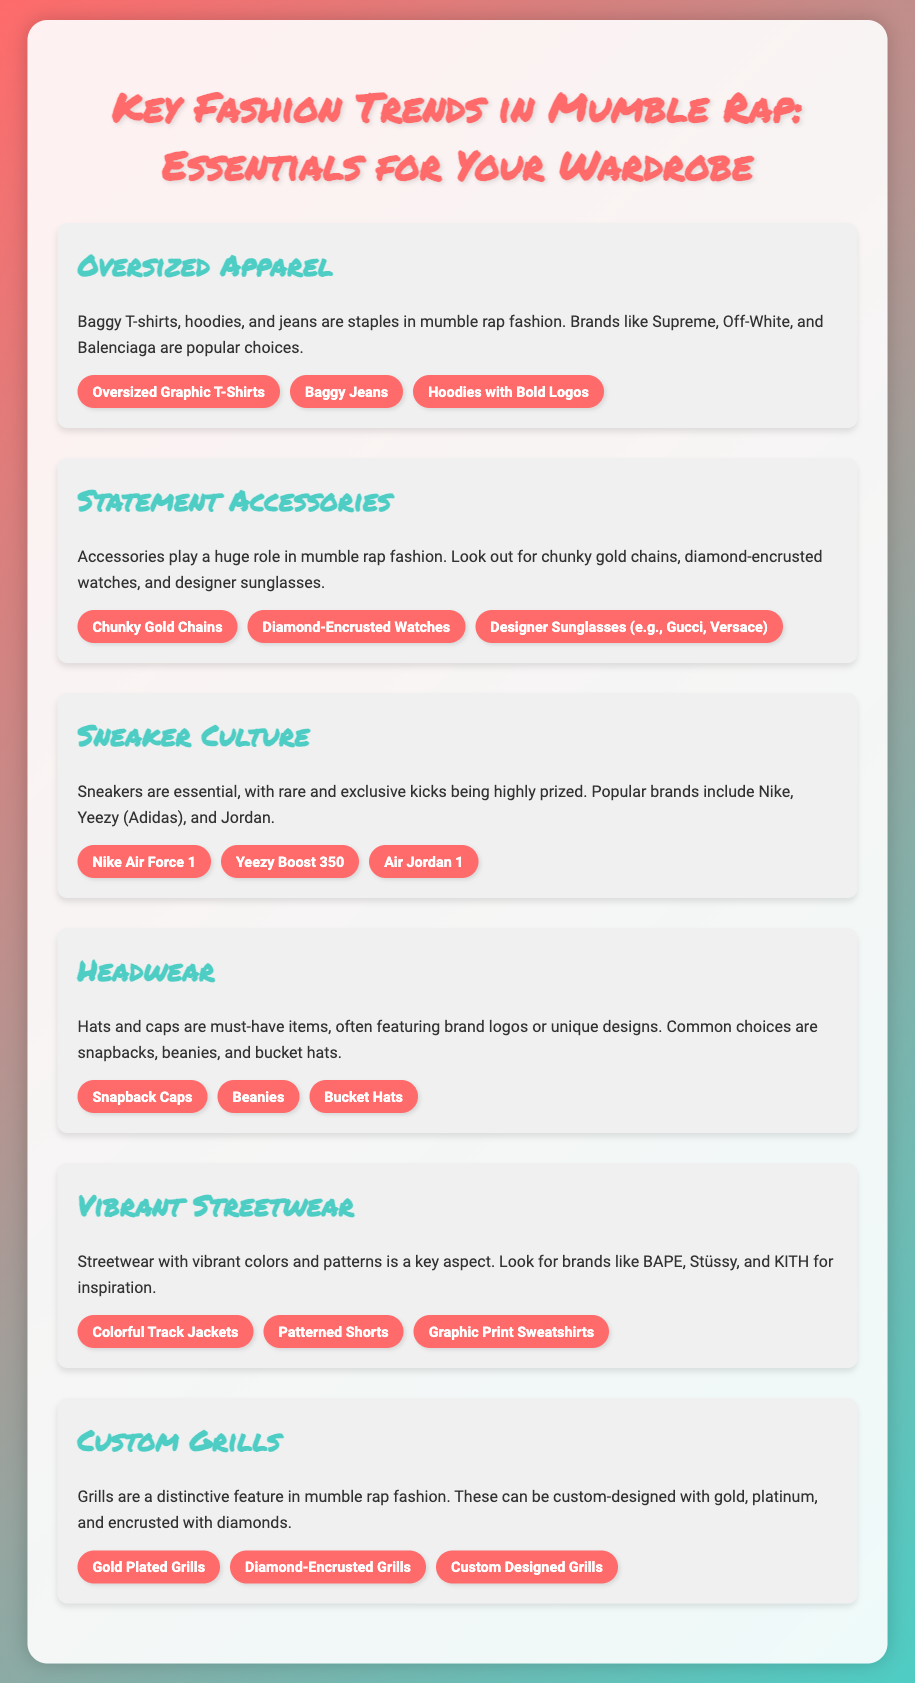What are the three categories of oversized apparel mentioned? The document lists oversized graphic t-shirts, baggy jeans, and hoodies with bold logos as key items in oversized apparel.
Answer: oversized graphic t-shirts, baggy jeans, hoodies with bold logos Which accessory is specifically listed as a must-have in mumble rap fashion? The document emphasizes that chunky gold chains are a significant accessory in mumble rap fashion.
Answer: chunky gold chains What is a popular sneaker brand mentioned in the document? The document specifically mentions Nike as a popular sneaker brand within the mumble rap culture.
Answer: Nike How many types of headwear are listed? The document includes three types of headwear: snapback caps, beanies, and bucket hats, indicating a total of three.
Answer: three What key feature distinguishes grills in mumble rap fashion? The document states that grills can be custom-designed with materials like gold or platinum and even encrusted with diamonds.
Answer: custom-designed with gold, platinum, and diamonds Which streetwear brand is mentioned as an inspiration? BAPE is one of the brands mentioned that provide inspiration for vibrant streetwear in the document.
Answer: BAPE 